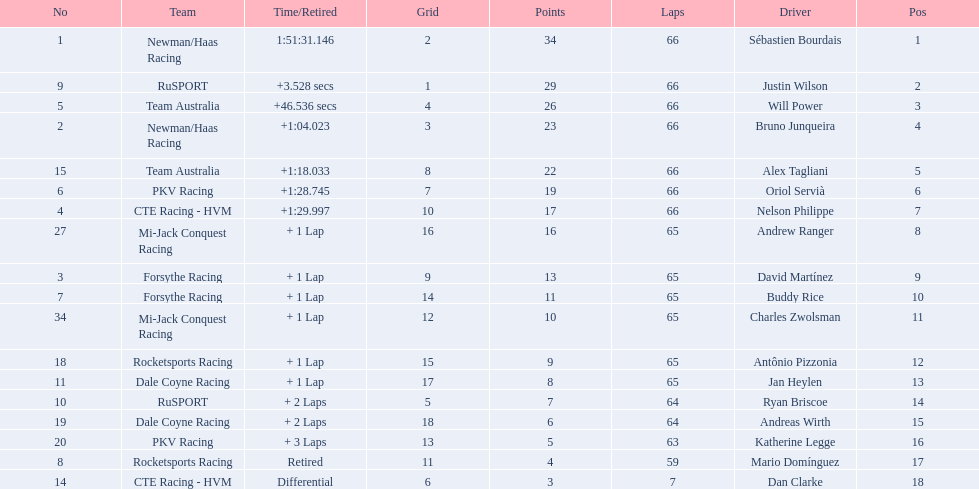At the 2006 gran premio telmex, who finished last? Dan Clarke. 